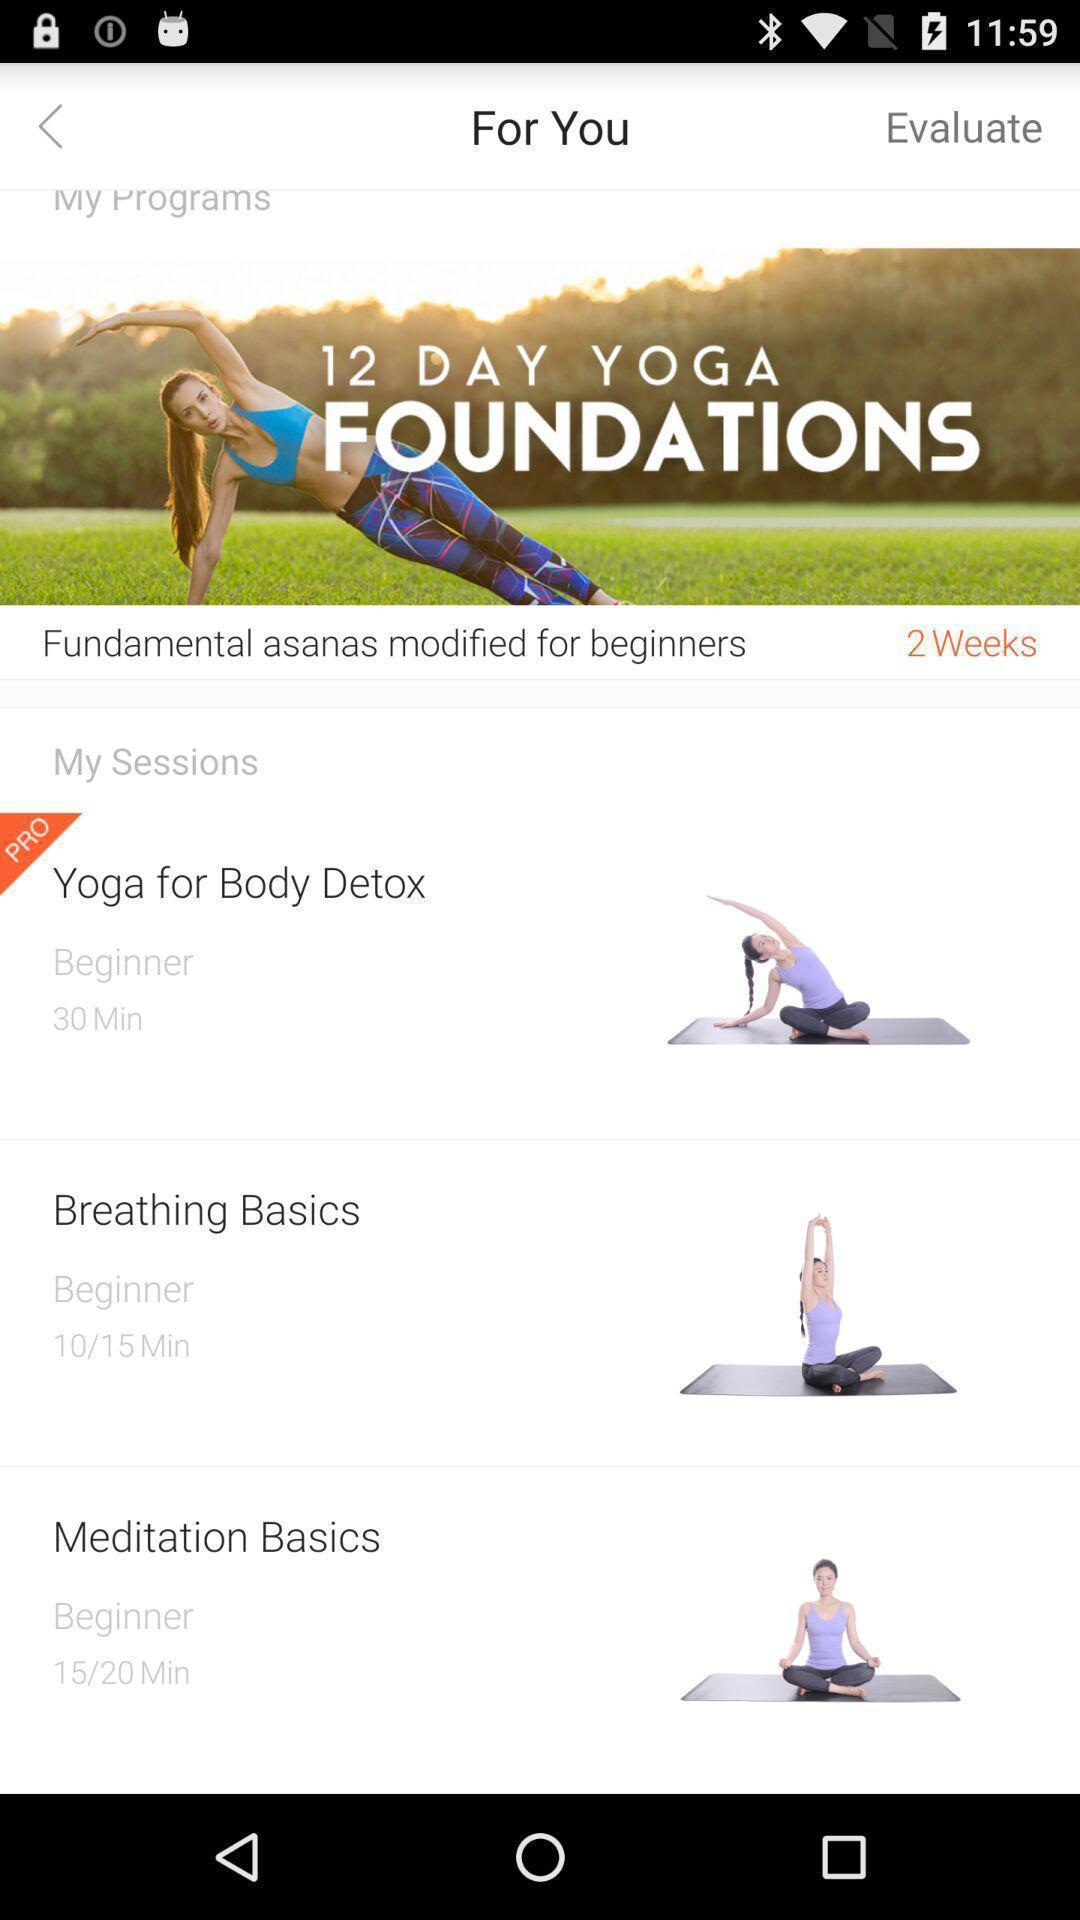Give me a summary of this screen capture. Screen displaying the page of yoga exercises app. 